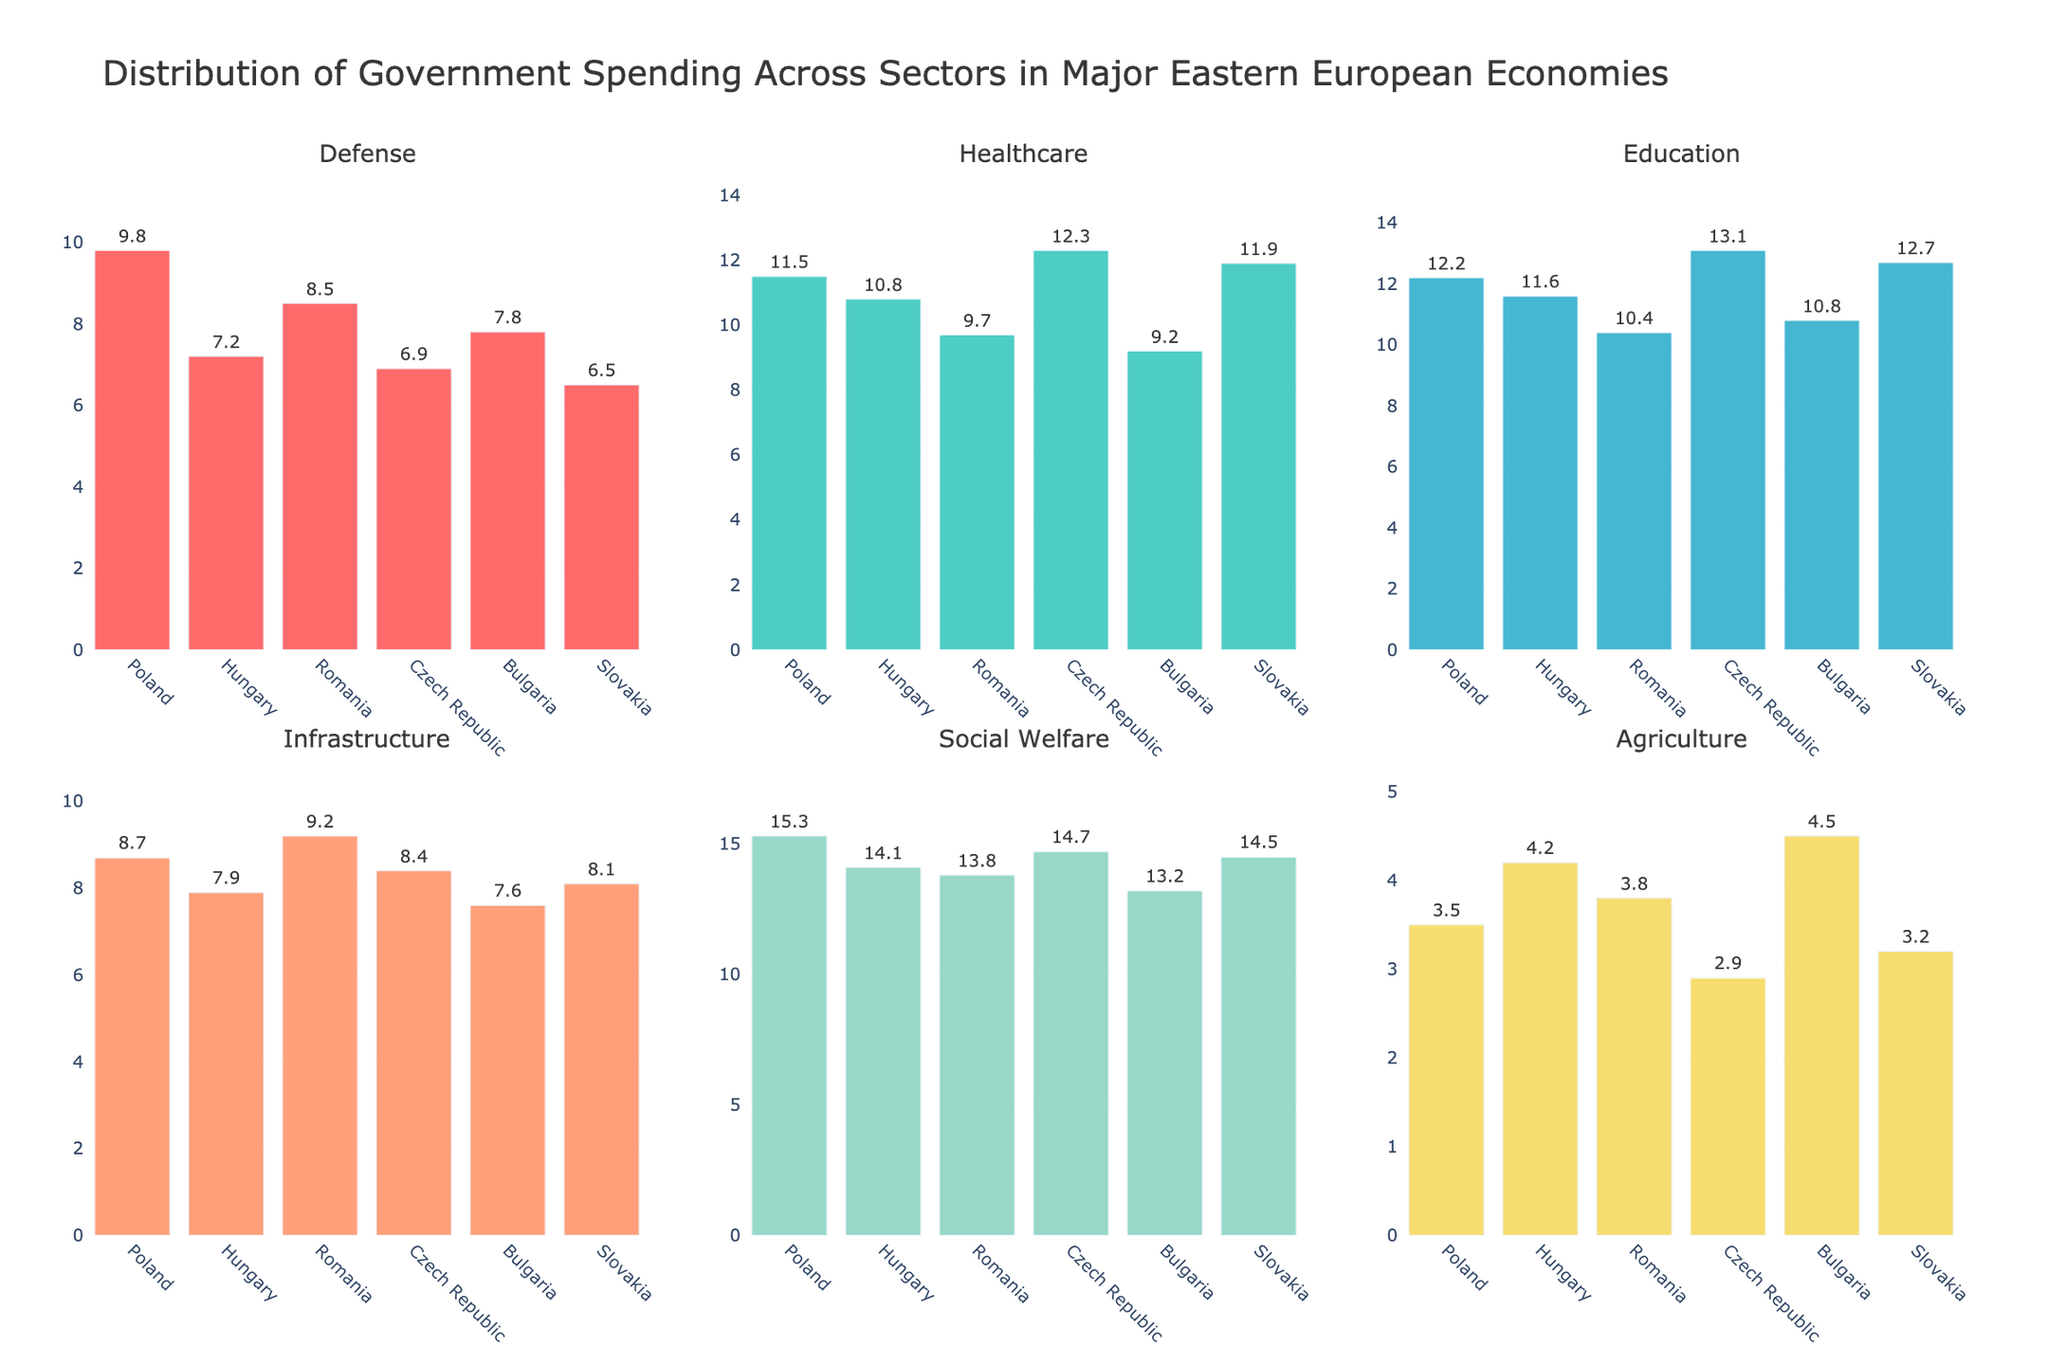Which country allocates the highest percentage of its budget to social welfare? The subplot for Social Welfare shows the expenditure percentages for all countries. The highest bar indicates the leading country.
Answer: Poland Which sector has the lowest spending across all the sectors for Slovakia? Look at the bars for Slovakia in each subplot and find the one with the smallest height.
Answer: Agriculture Compare the spending on healthcare between Poland and Hungary. Which country spends more and by how much? Refer to the Healthcare subplot and compare the heights of the bars for Poland and Hungary. Subtract Hungary’s spending from Poland’s to find the difference.
Answer: Poland by 0.7% What is the average spending on education across all countries? Sum the education spending values for all countries and divide by the number of countries (6). The values to sum are: 12.2, 11.6, 10.4, 13.1, 10.8, 12.7.
Answer: 11.8% Which country has the most balanced spending across all sectors? Observe each country across all subplots to identify the one with the least variation in bar heights.
Answer: Slovakia What is the difference between the highest and lowest spending sectors for Bulgaria? Identify the maximum and minimum values for Bulgaria across all subplots. Subtract the minimum from the maximum.
Answer: 8.7% Which two sectors combined have the highest total spending for Romania? Add the spending values for all possible pairs of sectors for Romania and identify the pair with the highest sum.
Answer: Social Welfare and Infrastructure Is there any country that spends more on infrastructure than on education? Compare the heights of the Infrastructure and Education bars for all countries.
Answer: No What is the total government spending on healthcare, combining all six countries? Sum the healthcare spending values across all six countries. The values to sum are: 11.5, 10.8, 9.7, 12.3, 9.2, 11.9.
Answer: 65.4% Which sector shows the most variation in spending across all countries? Examine all subplots and visually identify the sector with the widest range of bar heights.
Answer: Education 